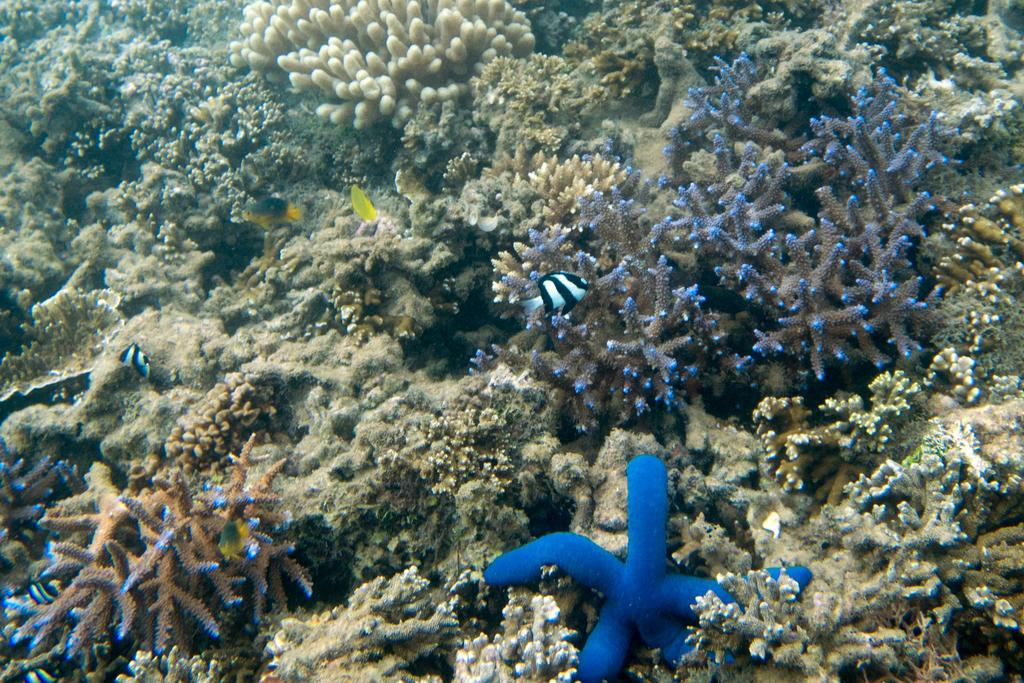What type of living organisms can be seen in the image? Plants and fish are visible in the image. Can you describe the environment in which the plants and fish are located? Unfortunately, the facts provided do not give enough information to describe the environment. What type of drain can be seen in the image? There is no drain present in the image. How does the pain affect the fish in the image? There is no indication of pain or any negative effect on the fish in the image. 